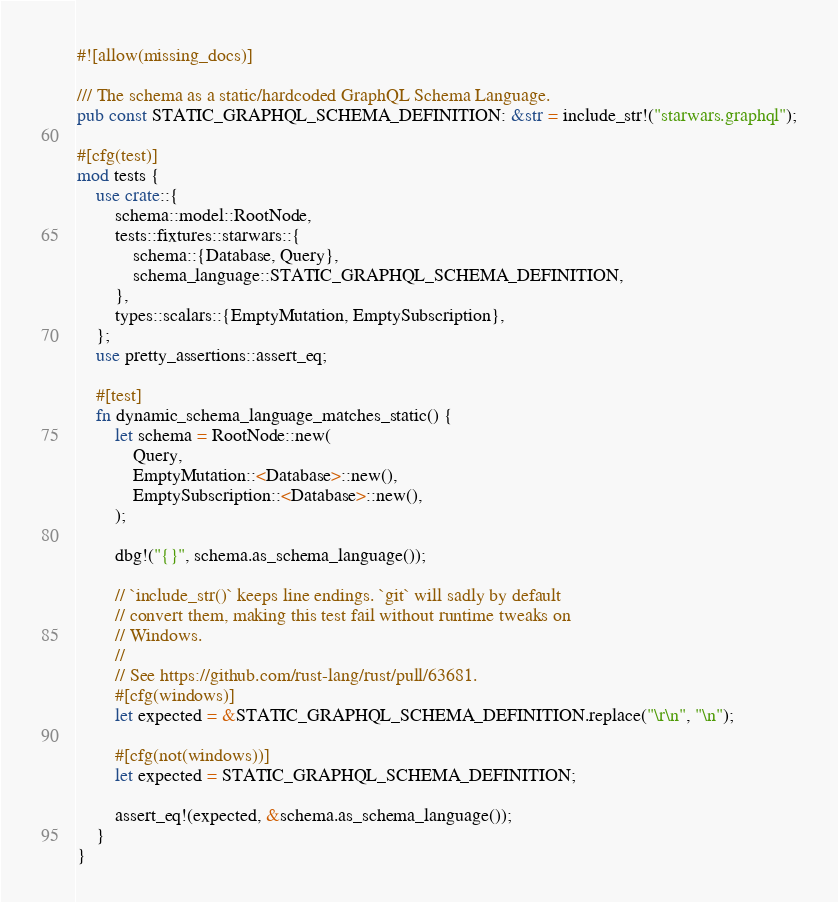Convert code to text. <code><loc_0><loc_0><loc_500><loc_500><_Rust_>#![allow(missing_docs)]

/// The schema as a static/hardcoded GraphQL Schema Language.
pub const STATIC_GRAPHQL_SCHEMA_DEFINITION: &str = include_str!("starwars.graphql");

#[cfg(test)]
mod tests {
    use crate::{
        schema::model::RootNode,
        tests::fixtures::starwars::{
            schema::{Database, Query},
            schema_language::STATIC_GRAPHQL_SCHEMA_DEFINITION,
        },
        types::scalars::{EmptyMutation, EmptySubscription},
    };
    use pretty_assertions::assert_eq;

    #[test]
    fn dynamic_schema_language_matches_static() {
        let schema = RootNode::new(
            Query,
            EmptyMutation::<Database>::new(),
            EmptySubscription::<Database>::new(),
        );

        dbg!("{}", schema.as_schema_language());

        // `include_str()` keeps line endings. `git` will sadly by default
        // convert them, making this test fail without runtime tweaks on
        // Windows.
        //
        // See https://github.com/rust-lang/rust/pull/63681.
        #[cfg(windows)]
        let expected = &STATIC_GRAPHQL_SCHEMA_DEFINITION.replace("\r\n", "\n");

        #[cfg(not(windows))]
        let expected = STATIC_GRAPHQL_SCHEMA_DEFINITION;

        assert_eq!(expected, &schema.as_schema_language());
    }
}
</code> 